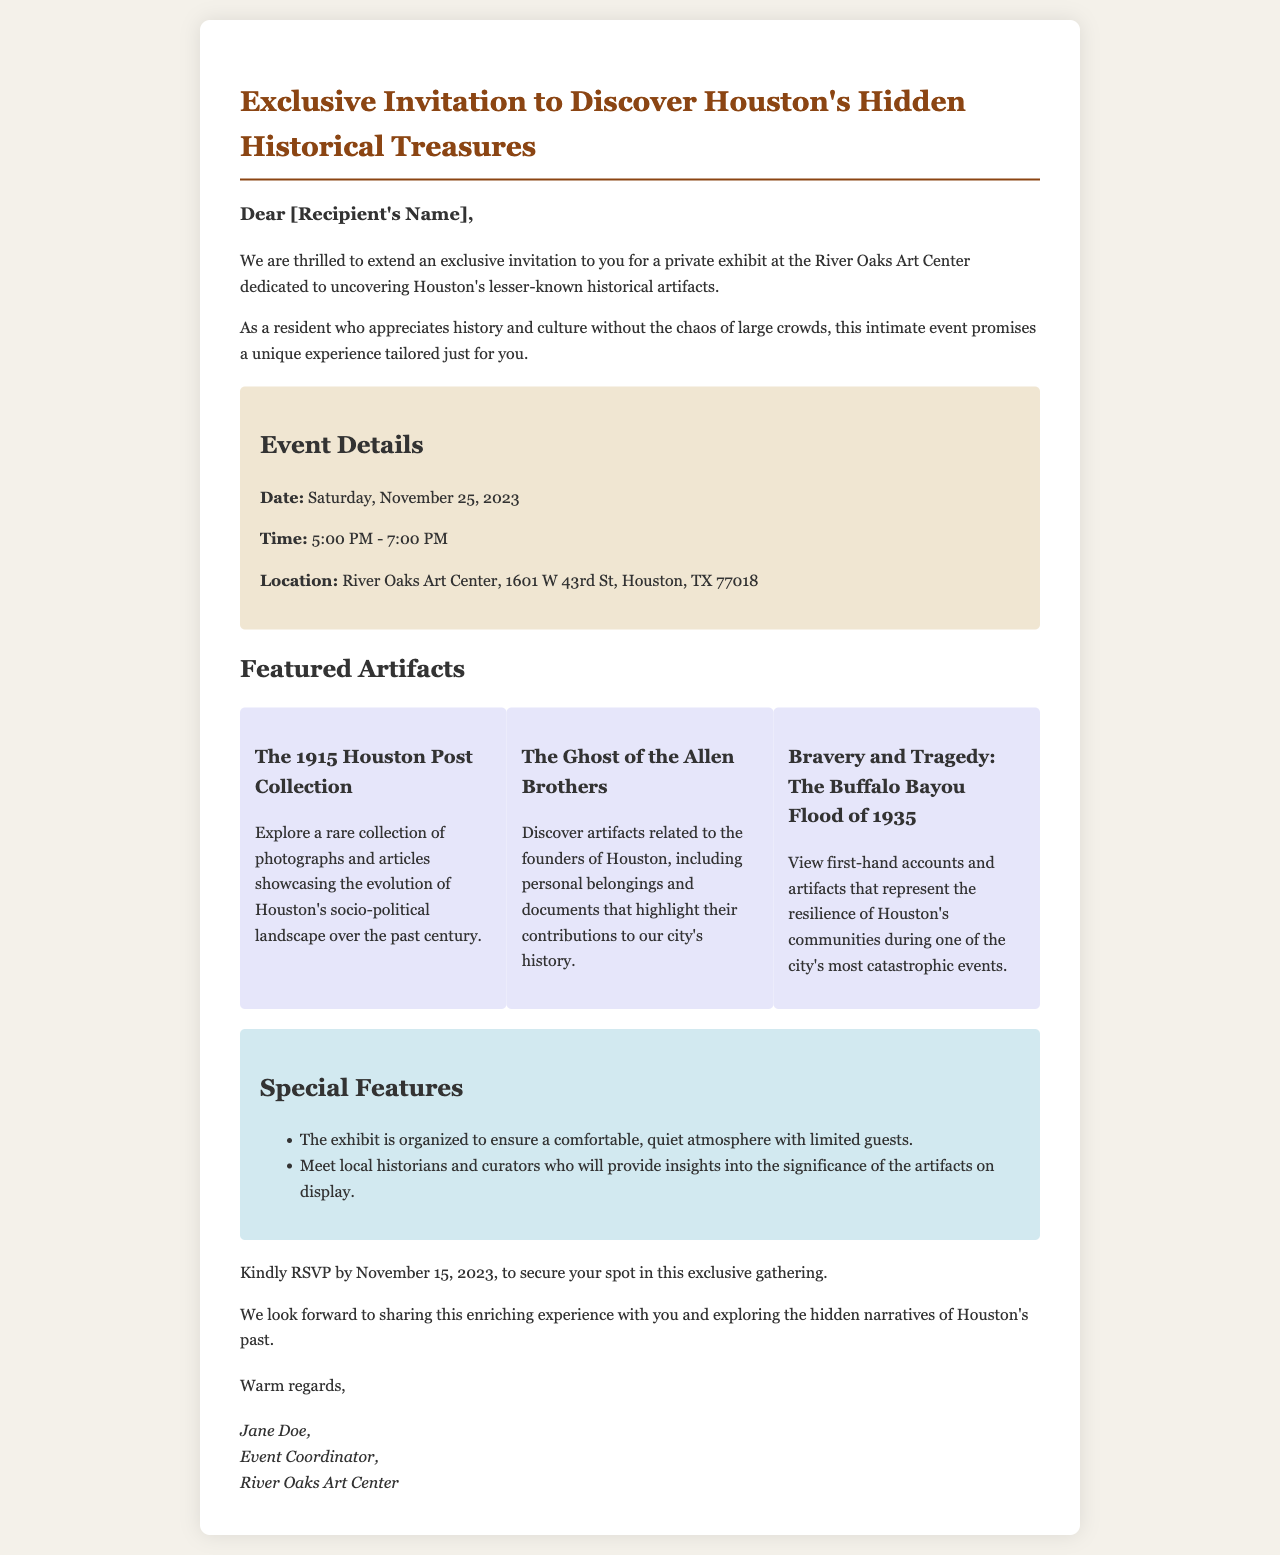What is the date of the event? The document specifies the date of the event as Saturday, November 25, 2023.
Answer: Saturday, November 25, 2023 What is the location of the exhibit? The exhibit is taking place at River Oaks Art Center, with the address provided in the document.
Answer: River Oaks Art Center, 1601 W 43rd St, Houston, TX 77018 Who is the event coordinator? The signature at the end of the document identifies Jane Doe as the event coordinator.
Answer: Jane Doe How long is the event scheduled to last? The event starts at 5:00 PM and ends at 7:00 PM, indicating a duration of 2 hours.
Answer: 2 hours What is one of the featured artifacts? The document lists several artifacts, one being "The 1915 Houston Post Collection."
Answer: The 1915 Houston Post Collection What is the RSVP deadline? According to the document, attendees are requested to RSVP by November 15, 2023.
Answer: November 15, 2023 How many guests will be allowed? The document mentions the exhibit is organized for limited guests to ensure a comfortable atmosphere.
Answer: Limited guests What benefit does attending the event provide? Attendees will have the opportunity to meet local historians and curators for insights into the artifacts.
Answer: Meet local historians and curators 